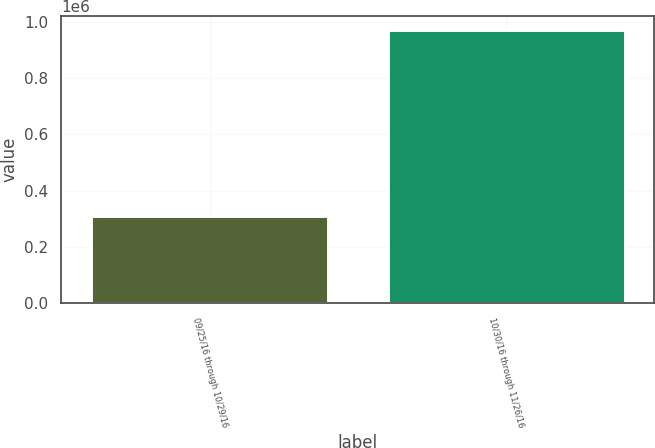<chart> <loc_0><loc_0><loc_500><loc_500><bar_chart><fcel>09/25/16 through 10/29/16<fcel>10/30/16 through 11/26/16<nl><fcel>310311<fcel>971031<nl></chart> 